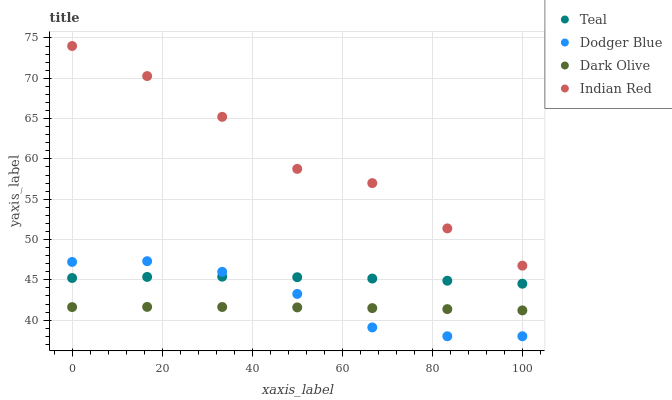Does Dark Olive have the minimum area under the curve?
Answer yes or no. Yes. Does Indian Red have the maximum area under the curve?
Answer yes or no. Yes. Does Dodger Blue have the minimum area under the curve?
Answer yes or no. No. Does Dodger Blue have the maximum area under the curve?
Answer yes or no. No. Is Dark Olive the smoothest?
Answer yes or no. Yes. Is Indian Red the roughest?
Answer yes or no. Yes. Is Dodger Blue the smoothest?
Answer yes or no. No. Is Dodger Blue the roughest?
Answer yes or no. No. Does Dodger Blue have the lowest value?
Answer yes or no. Yes. Does Indian Red have the lowest value?
Answer yes or no. No. Does Indian Red have the highest value?
Answer yes or no. Yes. Does Dodger Blue have the highest value?
Answer yes or no. No. Is Dodger Blue less than Indian Red?
Answer yes or no. Yes. Is Indian Red greater than Teal?
Answer yes or no. Yes. Does Dodger Blue intersect Teal?
Answer yes or no. Yes. Is Dodger Blue less than Teal?
Answer yes or no. No. Is Dodger Blue greater than Teal?
Answer yes or no. No. Does Dodger Blue intersect Indian Red?
Answer yes or no. No. 